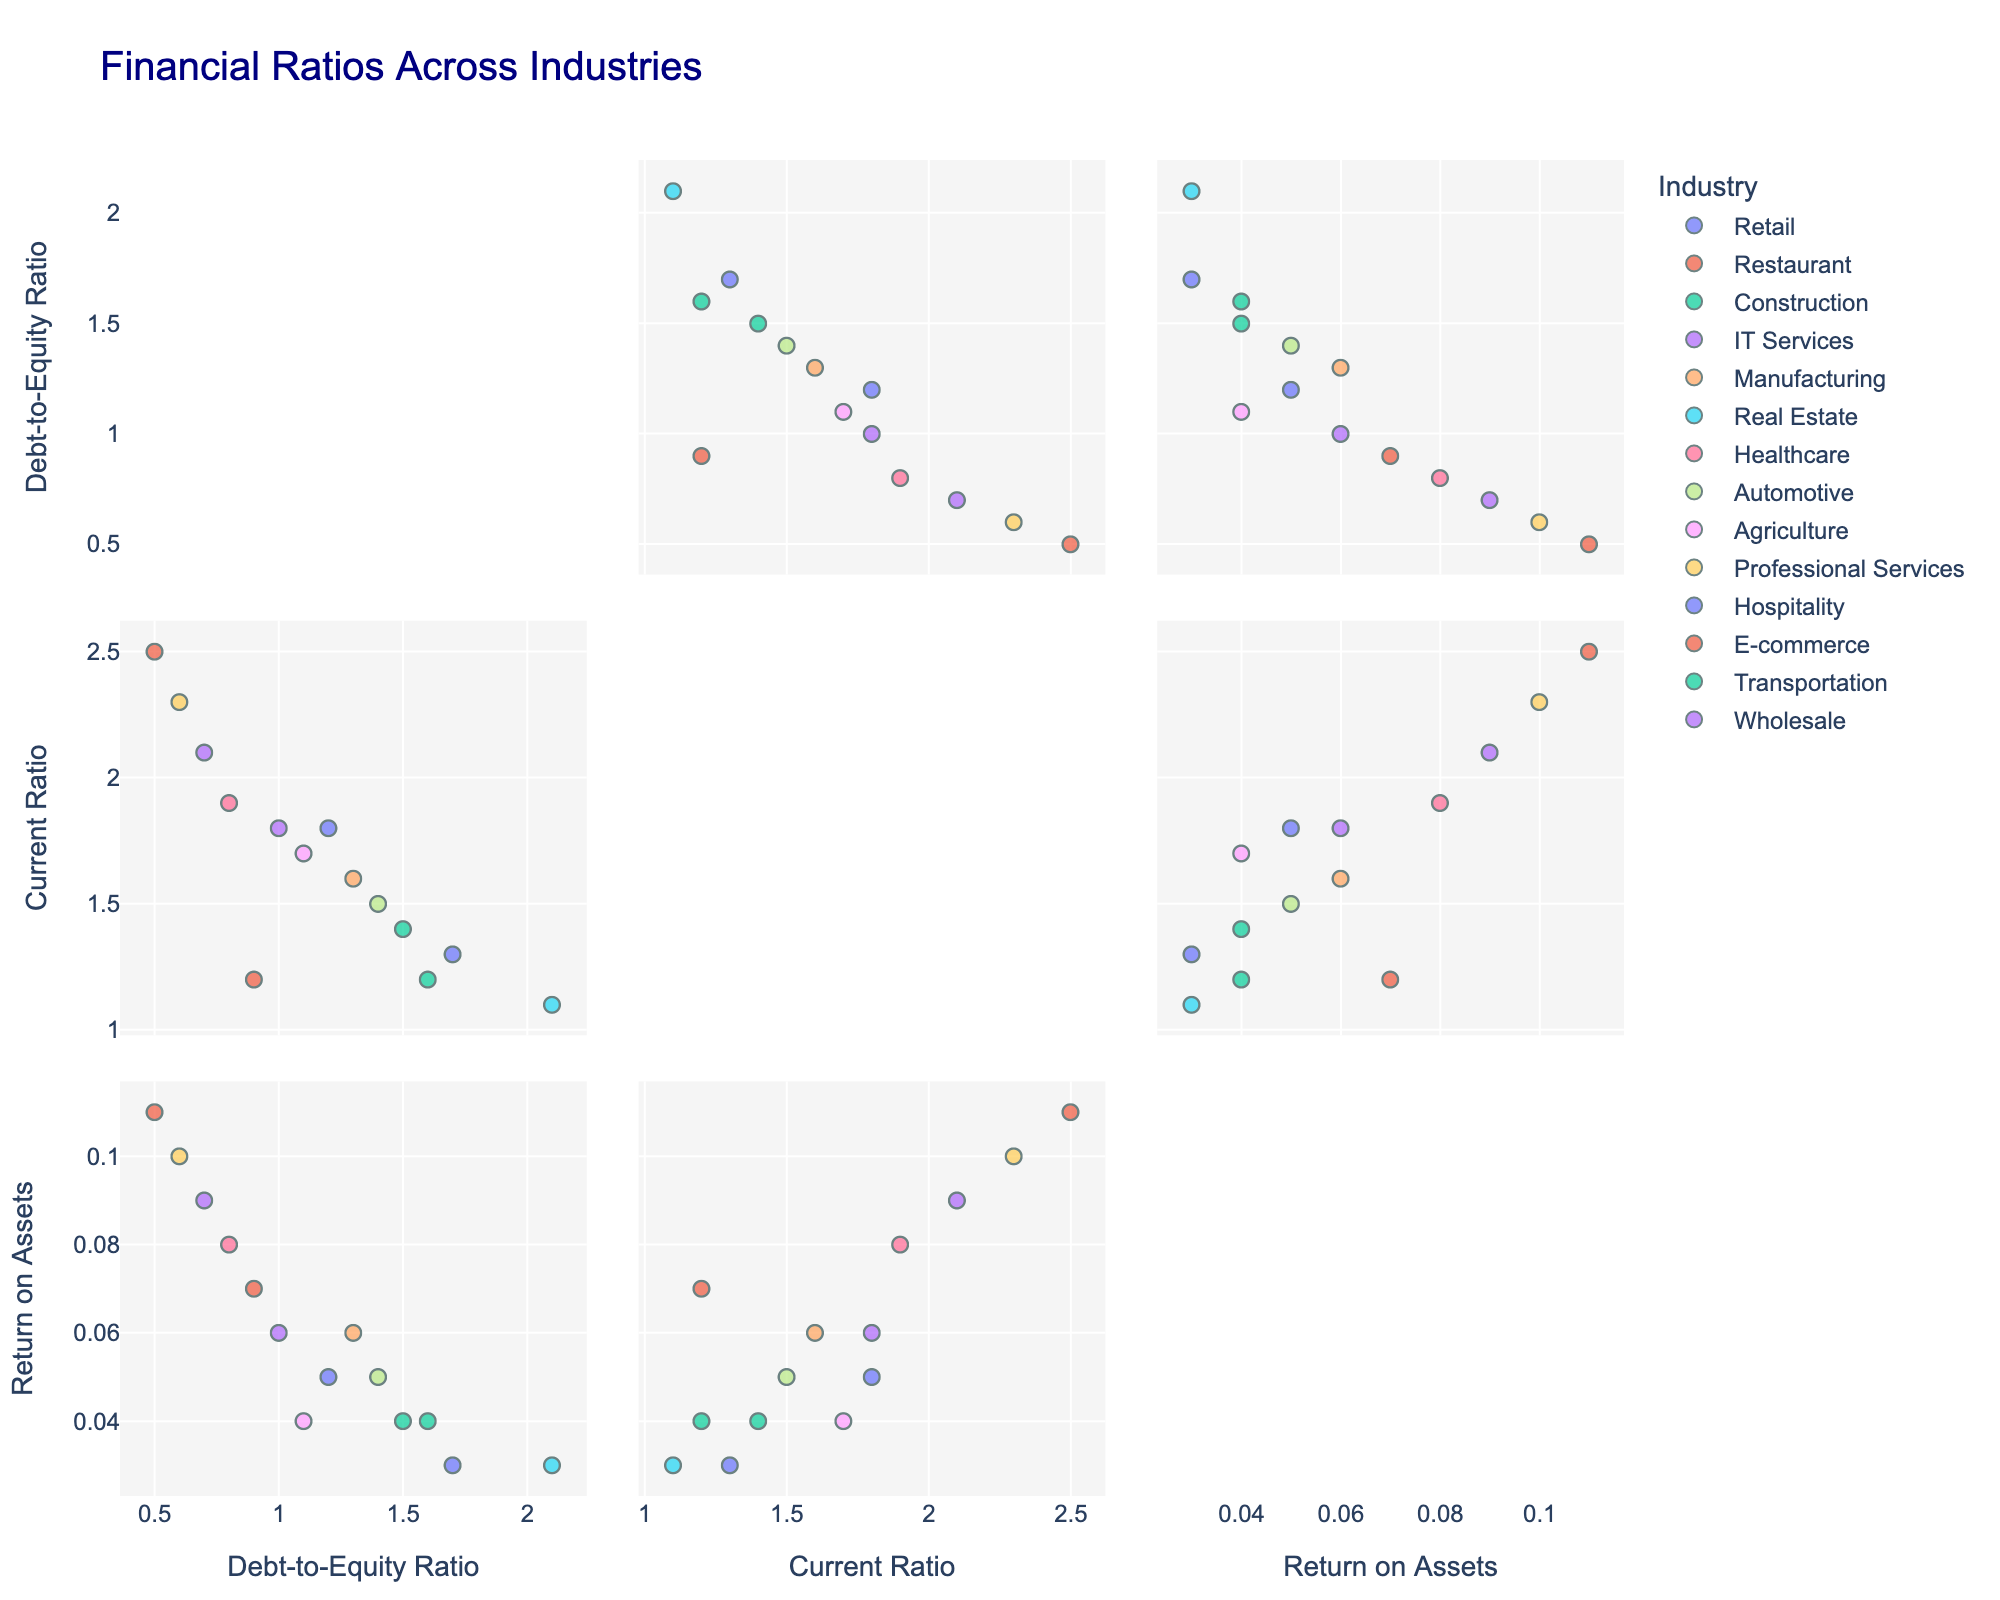What's the title of the figure? The title of the figure is displayed at the top and it summarizes what the figure is about.
Answer: Financial Ratios Across Industries Which industry has the highest Return on Assets? By looking at the axis representing Return on Assets and identifying the highest value, we can then check the corresponding industry label.
Answer: E-commerce How many industries are represented in the scatter plot matrix? Each industry is plotted with a different color, and the legend indicates the unique industry names. Counting these names gives the total number of industries.
Answer: 14 What is the Current Ratio of the Retail industry? By locating the points labeled as 'Retail' on the axes that represent the Current Ratio, we can identify the value.
Answer: 1.8 Which industry has a Debt-to-Equity Ratio less than 1.0 and also a Return on Assets greater than 0.08? We need to look for points positioned lower than 1.0 on the Debt-to-Equity axis and higher than 0.08 on the Return on Assets axis and then identify the corresponding industry.
Answer: IT Services What is the relationship between Debt-to-Equity Ratio and Return on Assets for the Construction industry? By examining the points representing the Construction industry across the Debt-to-Equity and Return on Assets axes, we can determine their relationship.
Answer: A higher Debt-to-Equity Ratio and a relatively low Return on Assets Which industry has a higher Current Ratio, Healthcare or Manufacturing? We compare the Current Ratio values for the points labeled 'Healthcare' and 'Manufacturing'.
Answer: Healthcare What is the median Current Ratio across all industries? First arrange all Current Ratio values in ascending order and find the middle value. In this case, since there are an even number of values, we take the average of the two central figures.
Answer: 1.7 Which two industries have the closest values for Return on Assets? By comparing the Return on Assets values across all industries, we identify the two that are nearest to each other.
Answer: Retail and Automotive What can you infer about industries with high Current Ratios based on the scatter plot matrix? By analyzing the trend in the scatter plot matrix, we observe the common characteristics and behaviors of industries plotted with high Current Ratios.
Answer: They often have lower Debt-to-Equity Ratios and higher Return on Assets 